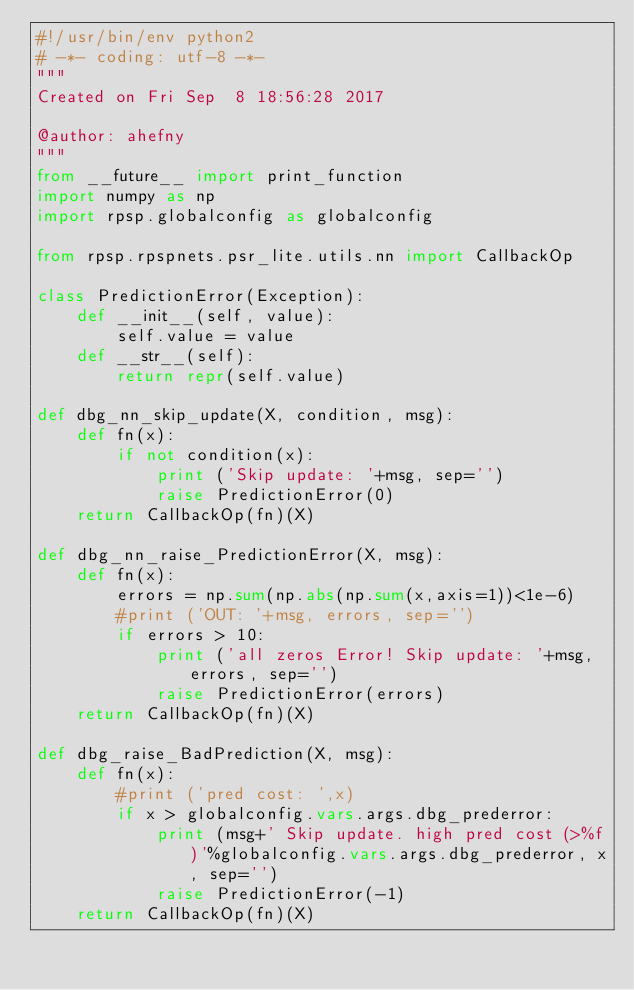Convert code to text. <code><loc_0><loc_0><loc_500><loc_500><_Python_>#!/usr/bin/env python2
# -*- coding: utf-8 -*-
"""
Created on Fri Sep  8 18:56:28 2017

@author: ahefny
"""
from __future__ import print_function
import numpy as np
import rpsp.globalconfig as globalconfig

from rpsp.rpspnets.psr_lite.utils.nn import CallbackOp

class PredictionError(Exception):
    def __init__(self, value):
        self.value = value
    def __str__(self):
        return repr(self.value)
    
def dbg_nn_skip_update(X, condition, msg):
    def fn(x):
        if not condition(x):
            print ('Skip update: '+msg, sep='')
            raise PredictionError(0)
    return CallbackOp(fn)(X)

def dbg_nn_raise_PredictionError(X, msg):
    def fn(x):
        errors = np.sum(np.abs(np.sum(x,axis=1))<1e-6)
        #print ('OUT: '+msg, errors, sep='')
        if errors > 10:
            print ('all zeros Error! Skip update: '+msg, errors, sep='')
            raise PredictionError(errors)
    return CallbackOp(fn)(X)

def dbg_raise_BadPrediction(X, msg):
    def fn(x):
        #print ('pred cost: ',x)
        if x > globalconfig.vars.args.dbg_prederror:
            print (msg+' Skip update. high pred cost (>%f)'%globalconfig.vars.args.dbg_prederror, x, sep='')
            raise PredictionError(-1)
    return CallbackOp(fn)(X)
</code> 